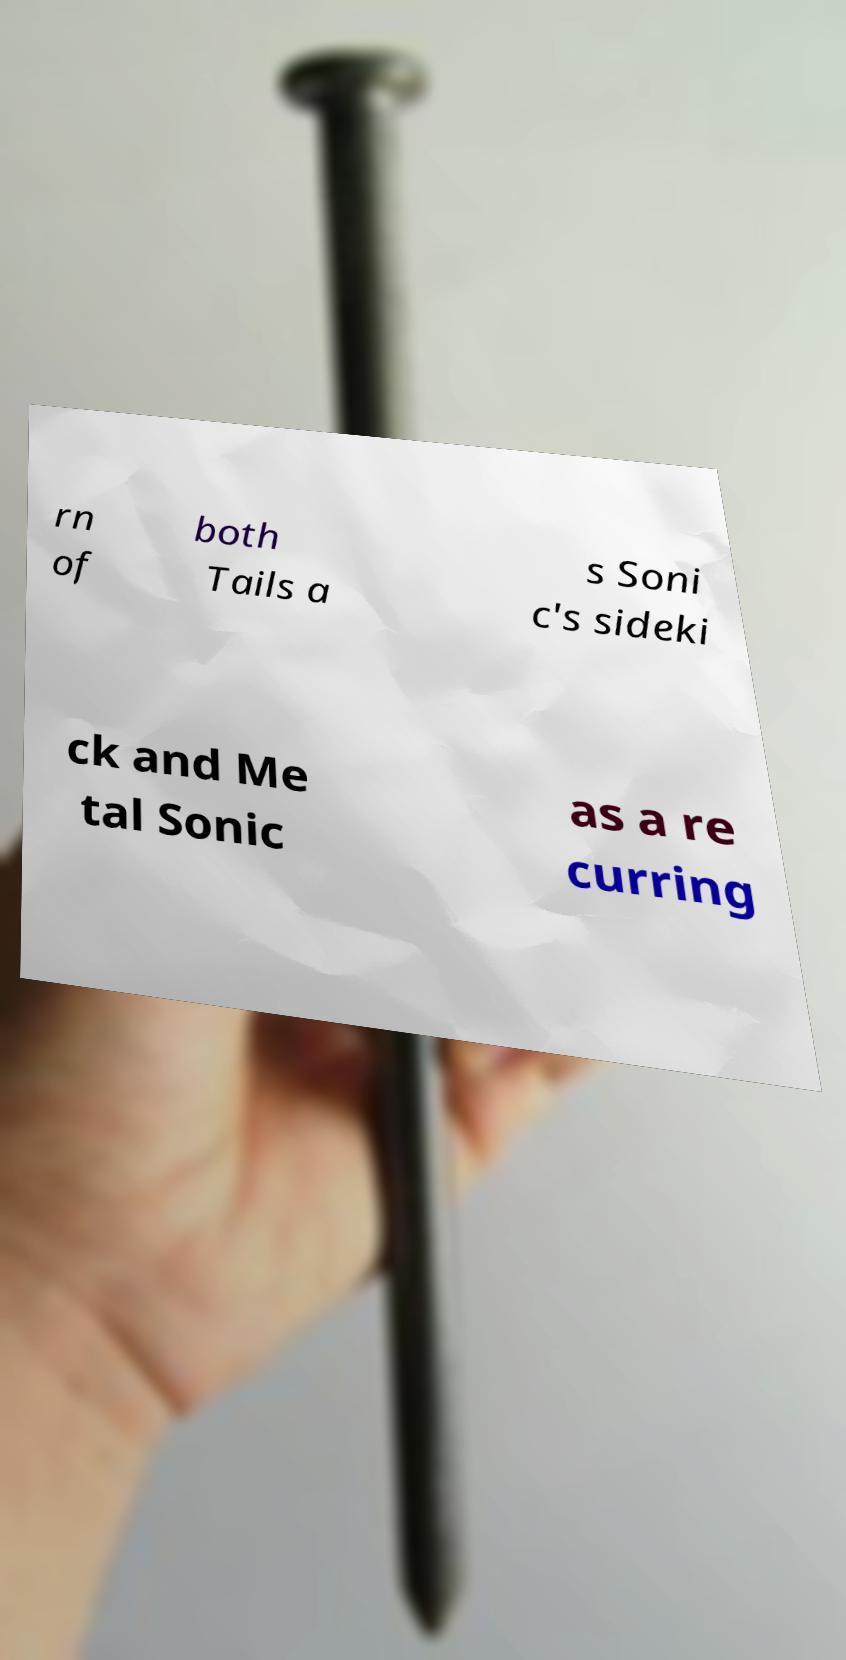What messages or text are displayed in this image? I need them in a readable, typed format. rn of both Tails a s Soni c's sideki ck and Me tal Sonic as a re curring 